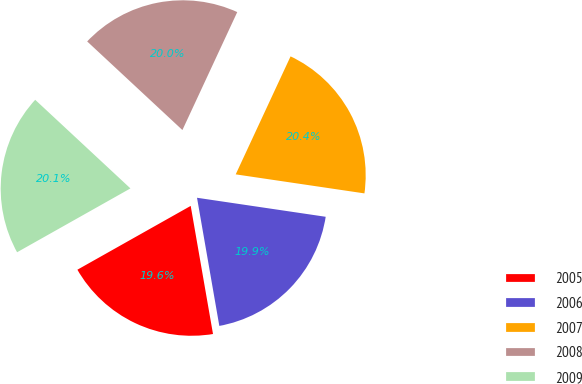Convert chart. <chart><loc_0><loc_0><loc_500><loc_500><pie_chart><fcel>2005<fcel>2006<fcel>2007<fcel>2008<fcel>2009<nl><fcel>19.58%<fcel>19.92%<fcel>20.41%<fcel>20.0%<fcel>20.09%<nl></chart> 